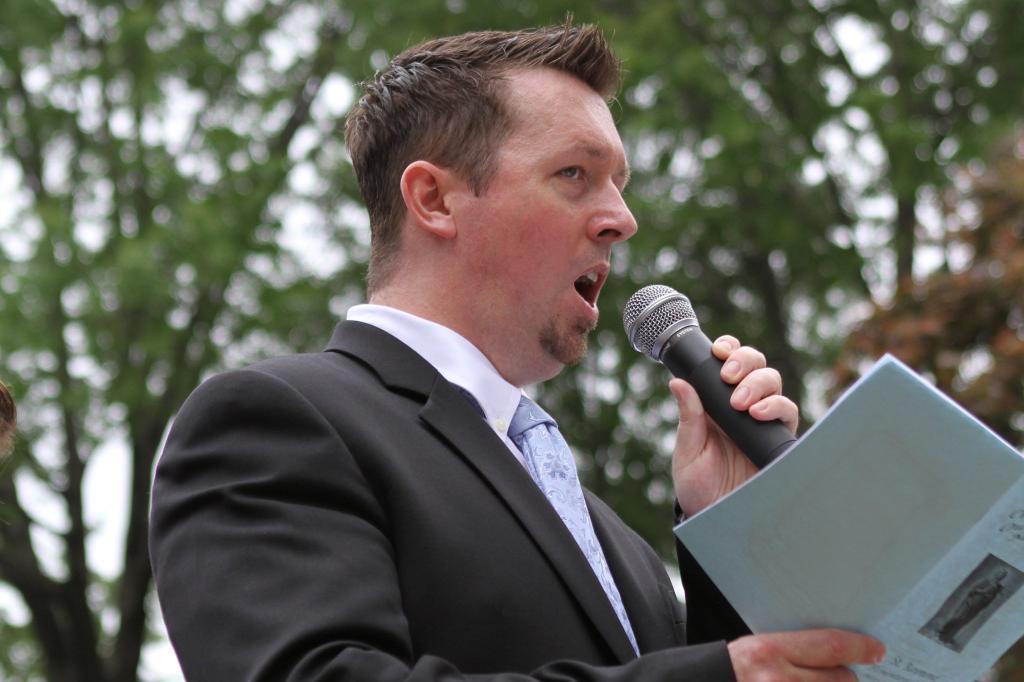In one or two sentences, can you explain what this image depicts? A man is speaking with a mic in his hand. He holds a book with another hand. He wears a black color suit. He has some trees in the background. 